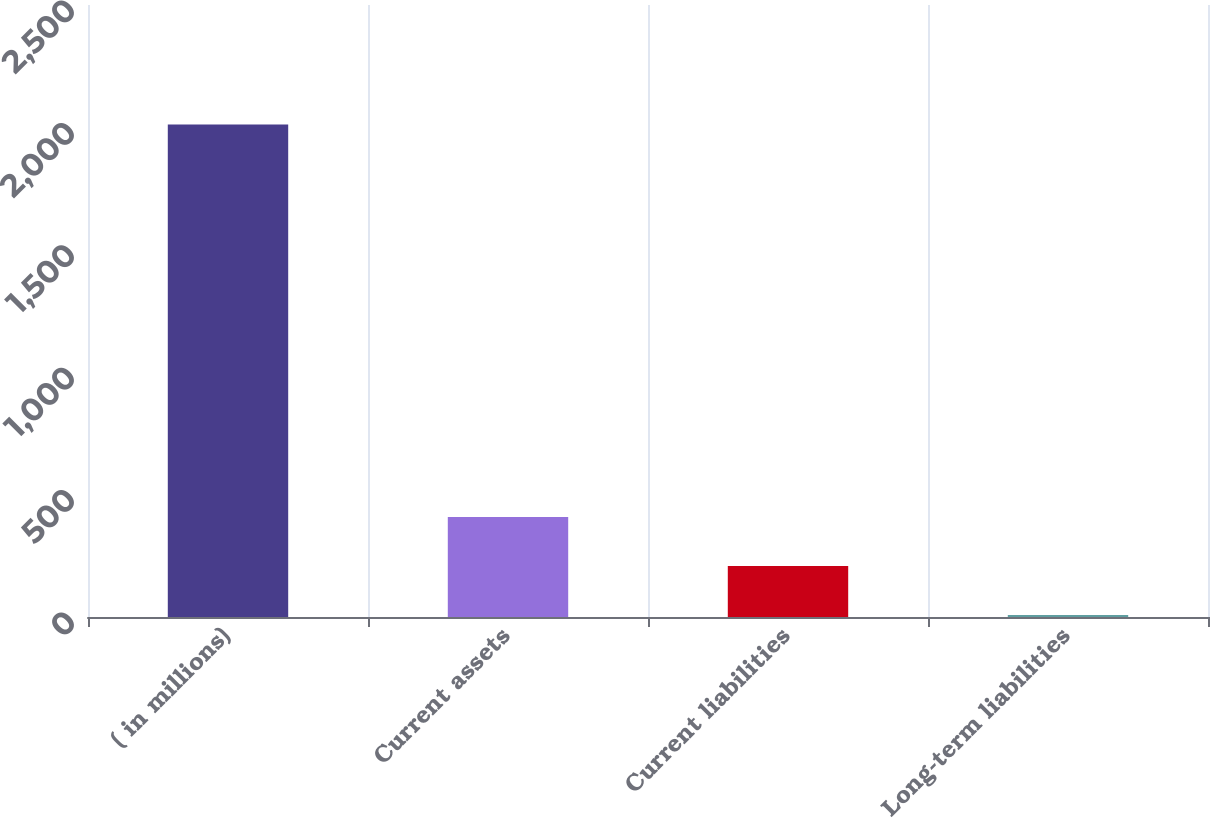<chart> <loc_0><loc_0><loc_500><loc_500><bar_chart><fcel>( in millions)<fcel>Current assets<fcel>Current liabilities<fcel>Long-term liabilities<nl><fcel>2012<fcel>408.8<fcel>208.4<fcel>8<nl></chart> 